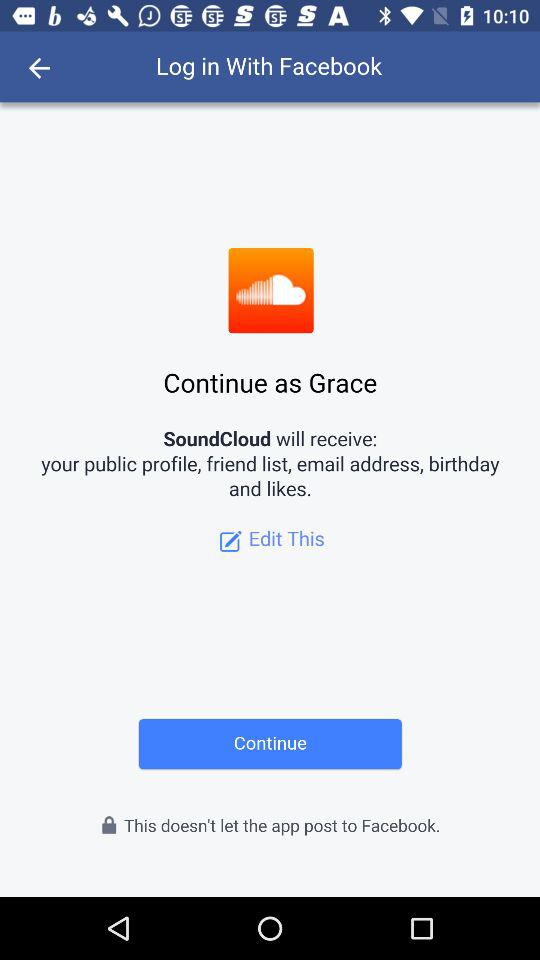What application is used for login? The application used for login is "Facebook". 